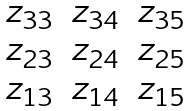<formula> <loc_0><loc_0><loc_500><loc_500>\begin{matrix} z _ { 3 3 } & z _ { 3 4 } & z _ { 3 5 } \\ z _ { 2 3 } & z _ { 2 4 } & z _ { 2 5 } \\ z _ { 1 3 } & z _ { 1 4 } & z _ { 1 5 } \end{matrix}</formula> 